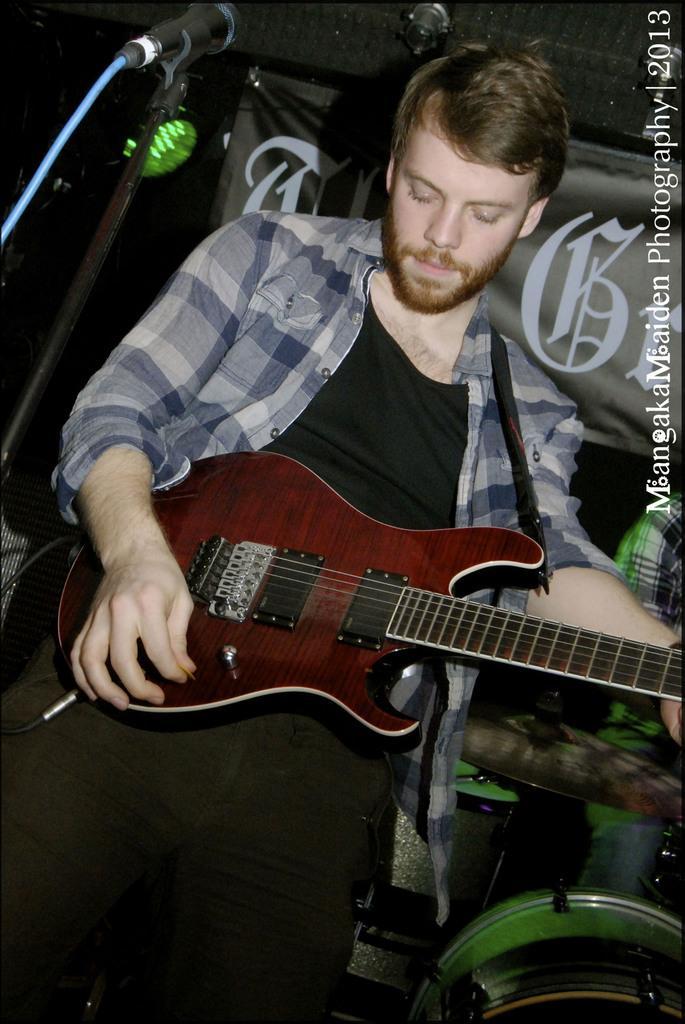How would you summarize this image in a sentence or two? On the background we can see a flexi, drums and a cymbal. Here we can see one man standing in front of a mike and playing guitar. 